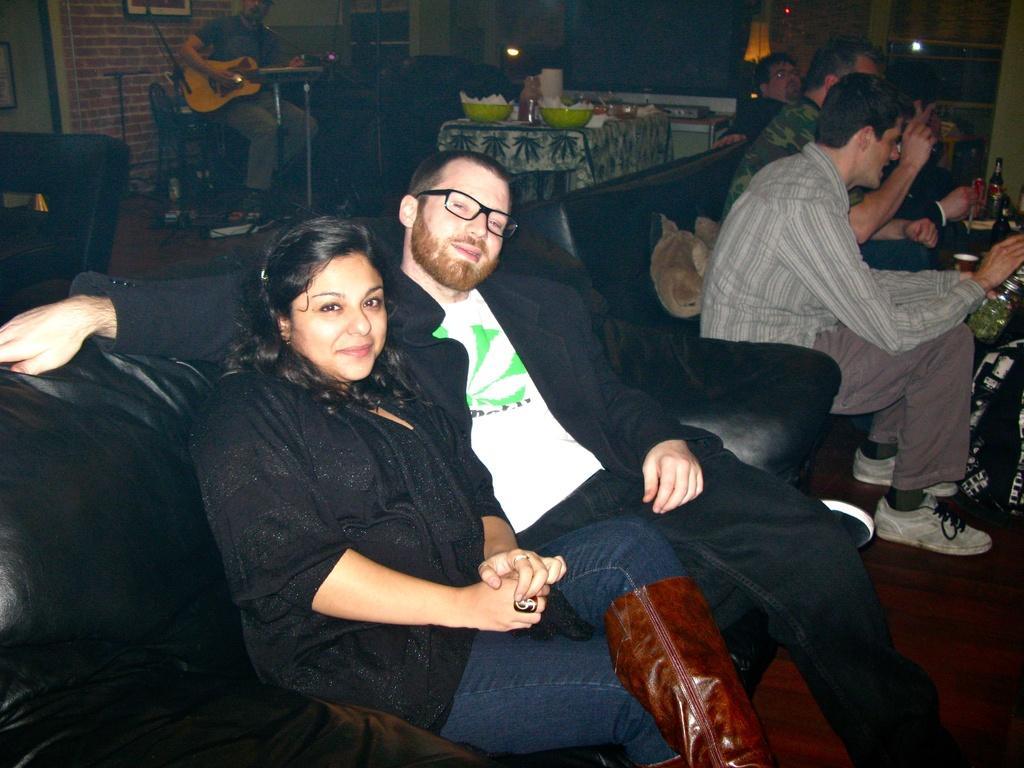Could you give a brief overview of what you see in this image? In the center of the image a lady and a man are sitting on a couch. At the top of the image there is a table. On the table we can see bowls, papers, bottle and some objects are there. On the right side of the image some persons are sitting on a couch and we can see doll and bottles are there. At the top left corner a man is playing a guitar and we can see wall, photo frame, lights are there. At the bottom of the image floor is there. 